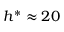<formula> <loc_0><loc_0><loc_500><loc_500>h ^ { * } \approx 2 0</formula> 